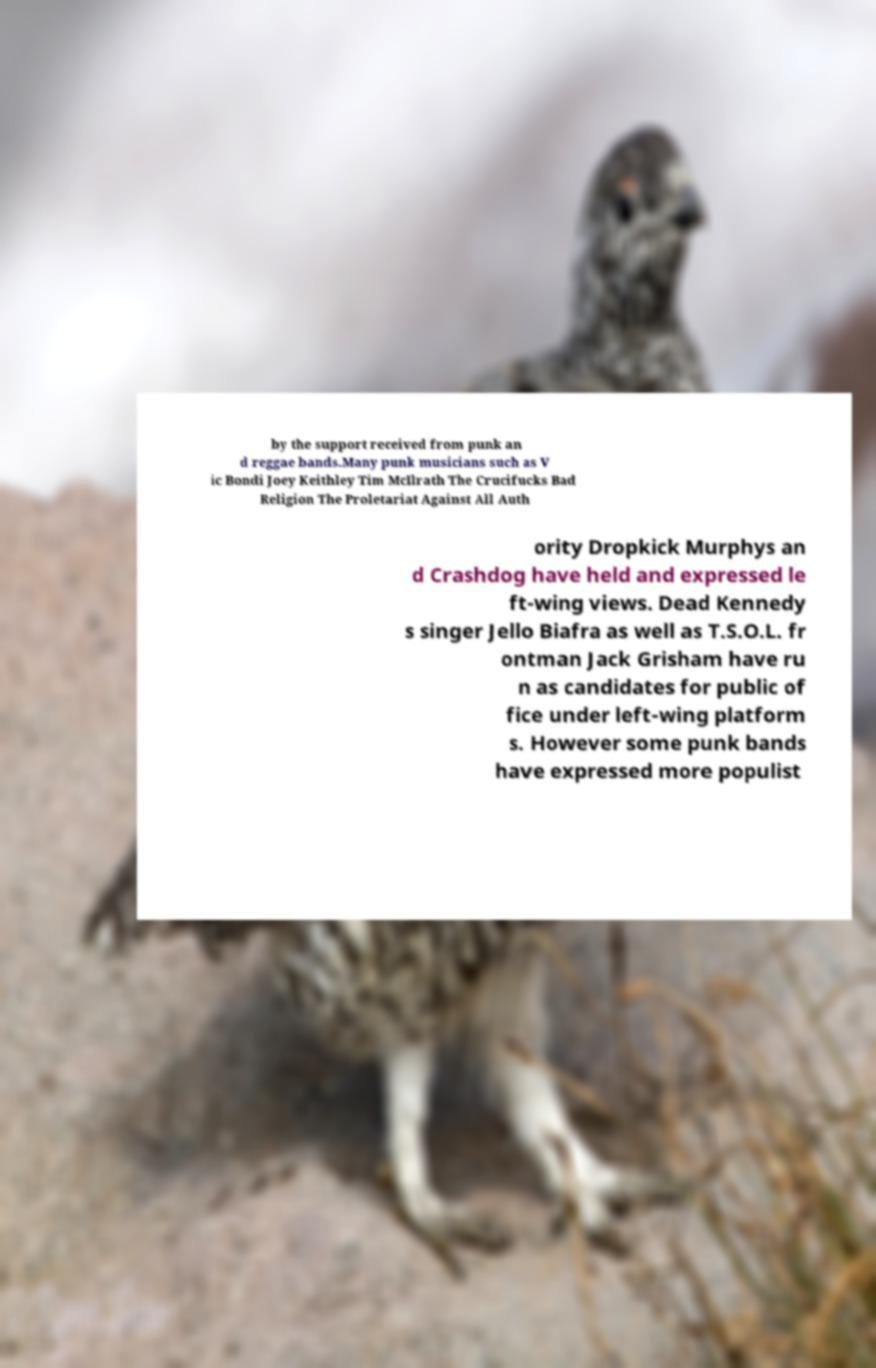Please read and relay the text visible in this image. What does it say? by the support received from punk an d reggae bands.Many punk musicians such as V ic Bondi Joey Keithley Tim McIlrath The Crucifucks Bad Religion The Proletariat Against All Auth ority Dropkick Murphys an d Crashdog have held and expressed le ft-wing views. Dead Kennedy s singer Jello Biafra as well as T.S.O.L. fr ontman Jack Grisham have ru n as candidates for public of fice under left-wing platform s. However some punk bands have expressed more populist 